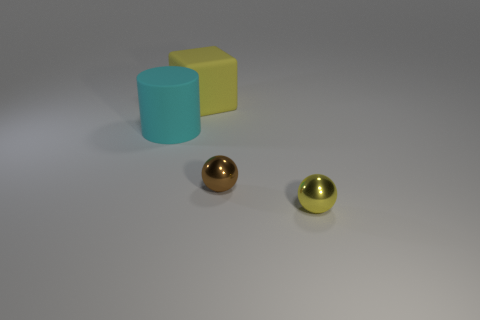Add 4 large blocks. How many objects exist? 8 Subtract all brown spheres. How many spheres are left? 1 Subtract 1 balls. How many balls are left? 1 Add 1 small brown shiny balls. How many small brown shiny balls exist? 2 Subtract 0 green cylinders. How many objects are left? 4 Subtract all cubes. How many objects are left? 3 Subtract all green cubes. Subtract all green cylinders. How many cubes are left? 1 Subtract all small gray balls. Subtract all small spheres. How many objects are left? 2 Add 4 yellow shiny spheres. How many yellow shiny spheres are left? 5 